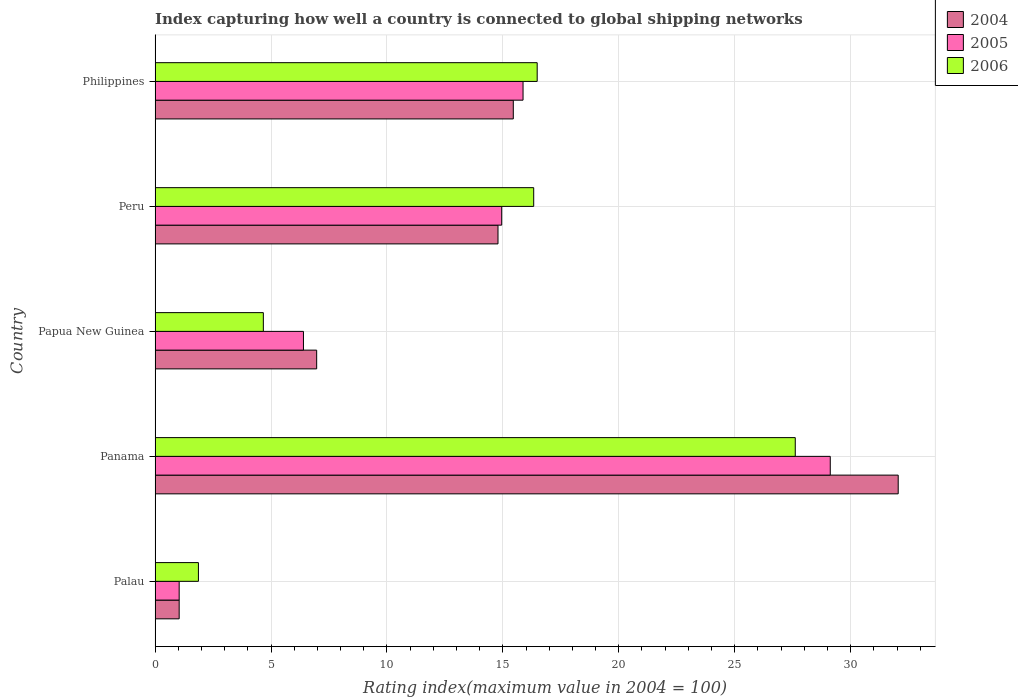How many different coloured bars are there?
Keep it short and to the point. 3. How many groups of bars are there?
Provide a short and direct response. 5. Are the number of bars per tick equal to the number of legend labels?
Offer a very short reply. Yes. What is the label of the 2nd group of bars from the top?
Provide a short and direct response. Peru. What is the rating index in 2004 in Panama?
Your answer should be very brief. 32.05. Across all countries, what is the maximum rating index in 2005?
Keep it short and to the point. 29.12. Across all countries, what is the minimum rating index in 2005?
Make the answer very short. 1.04. In which country was the rating index in 2004 maximum?
Your answer should be very brief. Panama. In which country was the rating index in 2004 minimum?
Your answer should be compact. Palau. What is the total rating index in 2005 in the graph?
Offer a terse response. 67.38. What is the difference between the rating index in 2006 in Papua New Guinea and that in Peru?
Make the answer very short. -11.66. What is the difference between the rating index in 2004 in Peru and the rating index in 2005 in Papua New Guinea?
Your answer should be compact. 8.39. What is the average rating index in 2004 per country?
Give a very brief answer. 14.06. What is the difference between the rating index in 2004 and rating index in 2006 in Palau?
Offer a terse response. -0.83. What is the ratio of the rating index in 2006 in Palau to that in Peru?
Your answer should be very brief. 0.11. Is the rating index in 2006 in Palau less than that in Philippines?
Your answer should be compact. Yes. Is the difference between the rating index in 2004 in Papua New Guinea and Peru greater than the difference between the rating index in 2006 in Papua New Guinea and Peru?
Your response must be concise. Yes. What is the difference between the highest and the second highest rating index in 2004?
Ensure brevity in your answer.  16.6. What is the difference between the highest and the lowest rating index in 2005?
Your answer should be compact. 28.08. In how many countries, is the rating index in 2004 greater than the average rating index in 2004 taken over all countries?
Make the answer very short. 3. What does the 2nd bar from the top in Philippines represents?
Provide a short and direct response. 2005. What does the 3rd bar from the bottom in Panama represents?
Give a very brief answer. 2006. Is it the case that in every country, the sum of the rating index in 2006 and rating index in 2005 is greater than the rating index in 2004?
Ensure brevity in your answer.  Yes. Are all the bars in the graph horizontal?
Offer a terse response. Yes. What is the difference between two consecutive major ticks on the X-axis?
Provide a succinct answer. 5. Are the values on the major ticks of X-axis written in scientific E-notation?
Your response must be concise. No. Does the graph contain any zero values?
Provide a succinct answer. No. Does the graph contain grids?
Offer a terse response. Yes. How many legend labels are there?
Your answer should be compact. 3. What is the title of the graph?
Ensure brevity in your answer.  Index capturing how well a country is connected to global shipping networks. What is the label or title of the X-axis?
Give a very brief answer. Rating index(maximum value in 2004 = 100). What is the Rating index(maximum value in 2004 = 100) in 2006 in Palau?
Your answer should be compact. 1.87. What is the Rating index(maximum value in 2004 = 100) in 2004 in Panama?
Make the answer very short. 32.05. What is the Rating index(maximum value in 2004 = 100) in 2005 in Panama?
Offer a terse response. 29.12. What is the Rating index(maximum value in 2004 = 100) of 2006 in Panama?
Provide a succinct answer. 27.61. What is the Rating index(maximum value in 2004 = 100) in 2004 in Papua New Guinea?
Keep it short and to the point. 6.97. What is the Rating index(maximum value in 2004 = 100) of 2006 in Papua New Guinea?
Your answer should be compact. 4.67. What is the Rating index(maximum value in 2004 = 100) of 2004 in Peru?
Offer a terse response. 14.79. What is the Rating index(maximum value in 2004 = 100) in 2005 in Peru?
Provide a short and direct response. 14.95. What is the Rating index(maximum value in 2004 = 100) in 2006 in Peru?
Provide a short and direct response. 16.33. What is the Rating index(maximum value in 2004 = 100) in 2004 in Philippines?
Provide a short and direct response. 15.45. What is the Rating index(maximum value in 2004 = 100) of 2005 in Philippines?
Your answer should be very brief. 15.87. What is the Rating index(maximum value in 2004 = 100) of 2006 in Philippines?
Provide a short and direct response. 16.48. Across all countries, what is the maximum Rating index(maximum value in 2004 = 100) in 2004?
Give a very brief answer. 32.05. Across all countries, what is the maximum Rating index(maximum value in 2004 = 100) in 2005?
Keep it short and to the point. 29.12. Across all countries, what is the maximum Rating index(maximum value in 2004 = 100) of 2006?
Keep it short and to the point. 27.61. Across all countries, what is the minimum Rating index(maximum value in 2004 = 100) in 2004?
Keep it short and to the point. 1.04. Across all countries, what is the minimum Rating index(maximum value in 2004 = 100) in 2005?
Provide a short and direct response. 1.04. Across all countries, what is the minimum Rating index(maximum value in 2004 = 100) of 2006?
Your answer should be compact. 1.87. What is the total Rating index(maximum value in 2004 = 100) in 2004 in the graph?
Give a very brief answer. 70.3. What is the total Rating index(maximum value in 2004 = 100) of 2005 in the graph?
Keep it short and to the point. 67.38. What is the total Rating index(maximum value in 2004 = 100) in 2006 in the graph?
Offer a terse response. 66.96. What is the difference between the Rating index(maximum value in 2004 = 100) of 2004 in Palau and that in Panama?
Your response must be concise. -31.01. What is the difference between the Rating index(maximum value in 2004 = 100) in 2005 in Palau and that in Panama?
Your response must be concise. -28.08. What is the difference between the Rating index(maximum value in 2004 = 100) of 2006 in Palau and that in Panama?
Make the answer very short. -25.74. What is the difference between the Rating index(maximum value in 2004 = 100) of 2004 in Palau and that in Papua New Guinea?
Ensure brevity in your answer.  -5.93. What is the difference between the Rating index(maximum value in 2004 = 100) in 2005 in Palau and that in Papua New Guinea?
Offer a terse response. -5.36. What is the difference between the Rating index(maximum value in 2004 = 100) of 2006 in Palau and that in Papua New Guinea?
Your response must be concise. -2.8. What is the difference between the Rating index(maximum value in 2004 = 100) of 2004 in Palau and that in Peru?
Provide a short and direct response. -13.75. What is the difference between the Rating index(maximum value in 2004 = 100) of 2005 in Palau and that in Peru?
Keep it short and to the point. -13.91. What is the difference between the Rating index(maximum value in 2004 = 100) of 2006 in Palau and that in Peru?
Your response must be concise. -14.46. What is the difference between the Rating index(maximum value in 2004 = 100) in 2004 in Palau and that in Philippines?
Your answer should be compact. -14.41. What is the difference between the Rating index(maximum value in 2004 = 100) in 2005 in Palau and that in Philippines?
Your response must be concise. -14.83. What is the difference between the Rating index(maximum value in 2004 = 100) of 2006 in Palau and that in Philippines?
Offer a very short reply. -14.61. What is the difference between the Rating index(maximum value in 2004 = 100) in 2004 in Panama and that in Papua New Guinea?
Ensure brevity in your answer.  25.08. What is the difference between the Rating index(maximum value in 2004 = 100) in 2005 in Panama and that in Papua New Guinea?
Your answer should be compact. 22.72. What is the difference between the Rating index(maximum value in 2004 = 100) of 2006 in Panama and that in Papua New Guinea?
Your answer should be very brief. 22.94. What is the difference between the Rating index(maximum value in 2004 = 100) in 2004 in Panama and that in Peru?
Offer a very short reply. 17.26. What is the difference between the Rating index(maximum value in 2004 = 100) in 2005 in Panama and that in Peru?
Give a very brief answer. 14.17. What is the difference between the Rating index(maximum value in 2004 = 100) in 2006 in Panama and that in Peru?
Your response must be concise. 11.28. What is the difference between the Rating index(maximum value in 2004 = 100) of 2004 in Panama and that in Philippines?
Give a very brief answer. 16.6. What is the difference between the Rating index(maximum value in 2004 = 100) of 2005 in Panama and that in Philippines?
Offer a very short reply. 13.25. What is the difference between the Rating index(maximum value in 2004 = 100) in 2006 in Panama and that in Philippines?
Provide a short and direct response. 11.13. What is the difference between the Rating index(maximum value in 2004 = 100) in 2004 in Papua New Guinea and that in Peru?
Keep it short and to the point. -7.82. What is the difference between the Rating index(maximum value in 2004 = 100) of 2005 in Papua New Guinea and that in Peru?
Offer a terse response. -8.55. What is the difference between the Rating index(maximum value in 2004 = 100) in 2006 in Papua New Guinea and that in Peru?
Provide a succinct answer. -11.66. What is the difference between the Rating index(maximum value in 2004 = 100) in 2004 in Papua New Guinea and that in Philippines?
Your answer should be compact. -8.48. What is the difference between the Rating index(maximum value in 2004 = 100) of 2005 in Papua New Guinea and that in Philippines?
Your response must be concise. -9.47. What is the difference between the Rating index(maximum value in 2004 = 100) of 2006 in Papua New Guinea and that in Philippines?
Your response must be concise. -11.81. What is the difference between the Rating index(maximum value in 2004 = 100) of 2004 in Peru and that in Philippines?
Your answer should be very brief. -0.66. What is the difference between the Rating index(maximum value in 2004 = 100) in 2005 in Peru and that in Philippines?
Your answer should be compact. -0.92. What is the difference between the Rating index(maximum value in 2004 = 100) of 2004 in Palau and the Rating index(maximum value in 2004 = 100) of 2005 in Panama?
Offer a very short reply. -28.08. What is the difference between the Rating index(maximum value in 2004 = 100) in 2004 in Palau and the Rating index(maximum value in 2004 = 100) in 2006 in Panama?
Provide a short and direct response. -26.57. What is the difference between the Rating index(maximum value in 2004 = 100) of 2005 in Palau and the Rating index(maximum value in 2004 = 100) of 2006 in Panama?
Ensure brevity in your answer.  -26.57. What is the difference between the Rating index(maximum value in 2004 = 100) in 2004 in Palau and the Rating index(maximum value in 2004 = 100) in 2005 in Papua New Guinea?
Keep it short and to the point. -5.36. What is the difference between the Rating index(maximum value in 2004 = 100) in 2004 in Palau and the Rating index(maximum value in 2004 = 100) in 2006 in Papua New Guinea?
Offer a terse response. -3.63. What is the difference between the Rating index(maximum value in 2004 = 100) of 2005 in Palau and the Rating index(maximum value in 2004 = 100) of 2006 in Papua New Guinea?
Provide a short and direct response. -3.63. What is the difference between the Rating index(maximum value in 2004 = 100) of 2004 in Palau and the Rating index(maximum value in 2004 = 100) of 2005 in Peru?
Make the answer very short. -13.91. What is the difference between the Rating index(maximum value in 2004 = 100) in 2004 in Palau and the Rating index(maximum value in 2004 = 100) in 2006 in Peru?
Offer a very short reply. -15.29. What is the difference between the Rating index(maximum value in 2004 = 100) of 2005 in Palau and the Rating index(maximum value in 2004 = 100) of 2006 in Peru?
Provide a succinct answer. -15.29. What is the difference between the Rating index(maximum value in 2004 = 100) of 2004 in Palau and the Rating index(maximum value in 2004 = 100) of 2005 in Philippines?
Give a very brief answer. -14.83. What is the difference between the Rating index(maximum value in 2004 = 100) in 2004 in Palau and the Rating index(maximum value in 2004 = 100) in 2006 in Philippines?
Make the answer very short. -15.44. What is the difference between the Rating index(maximum value in 2004 = 100) in 2005 in Palau and the Rating index(maximum value in 2004 = 100) in 2006 in Philippines?
Your response must be concise. -15.44. What is the difference between the Rating index(maximum value in 2004 = 100) of 2004 in Panama and the Rating index(maximum value in 2004 = 100) of 2005 in Papua New Guinea?
Offer a terse response. 25.65. What is the difference between the Rating index(maximum value in 2004 = 100) in 2004 in Panama and the Rating index(maximum value in 2004 = 100) in 2006 in Papua New Guinea?
Make the answer very short. 27.38. What is the difference between the Rating index(maximum value in 2004 = 100) in 2005 in Panama and the Rating index(maximum value in 2004 = 100) in 2006 in Papua New Guinea?
Provide a succinct answer. 24.45. What is the difference between the Rating index(maximum value in 2004 = 100) in 2004 in Panama and the Rating index(maximum value in 2004 = 100) in 2006 in Peru?
Your answer should be compact. 15.72. What is the difference between the Rating index(maximum value in 2004 = 100) in 2005 in Panama and the Rating index(maximum value in 2004 = 100) in 2006 in Peru?
Offer a very short reply. 12.79. What is the difference between the Rating index(maximum value in 2004 = 100) in 2004 in Panama and the Rating index(maximum value in 2004 = 100) in 2005 in Philippines?
Ensure brevity in your answer.  16.18. What is the difference between the Rating index(maximum value in 2004 = 100) of 2004 in Panama and the Rating index(maximum value in 2004 = 100) of 2006 in Philippines?
Your answer should be compact. 15.57. What is the difference between the Rating index(maximum value in 2004 = 100) of 2005 in Panama and the Rating index(maximum value in 2004 = 100) of 2006 in Philippines?
Ensure brevity in your answer.  12.64. What is the difference between the Rating index(maximum value in 2004 = 100) of 2004 in Papua New Guinea and the Rating index(maximum value in 2004 = 100) of 2005 in Peru?
Your response must be concise. -7.98. What is the difference between the Rating index(maximum value in 2004 = 100) in 2004 in Papua New Guinea and the Rating index(maximum value in 2004 = 100) in 2006 in Peru?
Your response must be concise. -9.36. What is the difference between the Rating index(maximum value in 2004 = 100) of 2005 in Papua New Guinea and the Rating index(maximum value in 2004 = 100) of 2006 in Peru?
Your answer should be compact. -9.93. What is the difference between the Rating index(maximum value in 2004 = 100) in 2004 in Papua New Guinea and the Rating index(maximum value in 2004 = 100) in 2005 in Philippines?
Ensure brevity in your answer.  -8.9. What is the difference between the Rating index(maximum value in 2004 = 100) of 2004 in Papua New Guinea and the Rating index(maximum value in 2004 = 100) of 2006 in Philippines?
Provide a short and direct response. -9.51. What is the difference between the Rating index(maximum value in 2004 = 100) in 2005 in Papua New Guinea and the Rating index(maximum value in 2004 = 100) in 2006 in Philippines?
Keep it short and to the point. -10.08. What is the difference between the Rating index(maximum value in 2004 = 100) of 2004 in Peru and the Rating index(maximum value in 2004 = 100) of 2005 in Philippines?
Your answer should be compact. -1.08. What is the difference between the Rating index(maximum value in 2004 = 100) in 2004 in Peru and the Rating index(maximum value in 2004 = 100) in 2006 in Philippines?
Keep it short and to the point. -1.69. What is the difference between the Rating index(maximum value in 2004 = 100) in 2005 in Peru and the Rating index(maximum value in 2004 = 100) in 2006 in Philippines?
Your response must be concise. -1.53. What is the average Rating index(maximum value in 2004 = 100) of 2004 per country?
Give a very brief answer. 14.06. What is the average Rating index(maximum value in 2004 = 100) of 2005 per country?
Offer a terse response. 13.48. What is the average Rating index(maximum value in 2004 = 100) in 2006 per country?
Offer a very short reply. 13.39. What is the difference between the Rating index(maximum value in 2004 = 100) in 2004 and Rating index(maximum value in 2004 = 100) in 2006 in Palau?
Keep it short and to the point. -0.83. What is the difference between the Rating index(maximum value in 2004 = 100) in 2005 and Rating index(maximum value in 2004 = 100) in 2006 in Palau?
Your response must be concise. -0.83. What is the difference between the Rating index(maximum value in 2004 = 100) of 2004 and Rating index(maximum value in 2004 = 100) of 2005 in Panama?
Make the answer very short. 2.93. What is the difference between the Rating index(maximum value in 2004 = 100) in 2004 and Rating index(maximum value in 2004 = 100) in 2006 in Panama?
Your response must be concise. 4.44. What is the difference between the Rating index(maximum value in 2004 = 100) in 2005 and Rating index(maximum value in 2004 = 100) in 2006 in Panama?
Your answer should be very brief. 1.51. What is the difference between the Rating index(maximum value in 2004 = 100) of 2004 and Rating index(maximum value in 2004 = 100) of 2005 in Papua New Guinea?
Ensure brevity in your answer.  0.57. What is the difference between the Rating index(maximum value in 2004 = 100) in 2005 and Rating index(maximum value in 2004 = 100) in 2006 in Papua New Guinea?
Give a very brief answer. 1.73. What is the difference between the Rating index(maximum value in 2004 = 100) in 2004 and Rating index(maximum value in 2004 = 100) in 2005 in Peru?
Provide a short and direct response. -0.16. What is the difference between the Rating index(maximum value in 2004 = 100) of 2004 and Rating index(maximum value in 2004 = 100) of 2006 in Peru?
Provide a succinct answer. -1.54. What is the difference between the Rating index(maximum value in 2004 = 100) in 2005 and Rating index(maximum value in 2004 = 100) in 2006 in Peru?
Offer a terse response. -1.38. What is the difference between the Rating index(maximum value in 2004 = 100) in 2004 and Rating index(maximum value in 2004 = 100) in 2005 in Philippines?
Give a very brief answer. -0.42. What is the difference between the Rating index(maximum value in 2004 = 100) of 2004 and Rating index(maximum value in 2004 = 100) of 2006 in Philippines?
Your answer should be compact. -1.03. What is the difference between the Rating index(maximum value in 2004 = 100) of 2005 and Rating index(maximum value in 2004 = 100) of 2006 in Philippines?
Provide a short and direct response. -0.61. What is the ratio of the Rating index(maximum value in 2004 = 100) in 2004 in Palau to that in Panama?
Offer a terse response. 0.03. What is the ratio of the Rating index(maximum value in 2004 = 100) in 2005 in Palau to that in Panama?
Provide a short and direct response. 0.04. What is the ratio of the Rating index(maximum value in 2004 = 100) in 2006 in Palau to that in Panama?
Your response must be concise. 0.07. What is the ratio of the Rating index(maximum value in 2004 = 100) of 2004 in Palau to that in Papua New Guinea?
Your answer should be very brief. 0.15. What is the ratio of the Rating index(maximum value in 2004 = 100) of 2005 in Palau to that in Papua New Guinea?
Your response must be concise. 0.16. What is the ratio of the Rating index(maximum value in 2004 = 100) of 2006 in Palau to that in Papua New Guinea?
Your answer should be very brief. 0.4. What is the ratio of the Rating index(maximum value in 2004 = 100) in 2004 in Palau to that in Peru?
Your response must be concise. 0.07. What is the ratio of the Rating index(maximum value in 2004 = 100) in 2005 in Palau to that in Peru?
Provide a succinct answer. 0.07. What is the ratio of the Rating index(maximum value in 2004 = 100) in 2006 in Palau to that in Peru?
Offer a terse response. 0.11. What is the ratio of the Rating index(maximum value in 2004 = 100) in 2004 in Palau to that in Philippines?
Offer a very short reply. 0.07. What is the ratio of the Rating index(maximum value in 2004 = 100) in 2005 in Palau to that in Philippines?
Offer a very short reply. 0.07. What is the ratio of the Rating index(maximum value in 2004 = 100) in 2006 in Palau to that in Philippines?
Your response must be concise. 0.11. What is the ratio of the Rating index(maximum value in 2004 = 100) in 2004 in Panama to that in Papua New Guinea?
Provide a succinct answer. 4.6. What is the ratio of the Rating index(maximum value in 2004 = 100) of 2005 in Panama to that in Papua New Guinea?
Ensure brevity in your answer.  4.55. What is the ratio of the Rating index(maximum value in 2004 = 100) of 2006 in Panama to that in Papua New Guinea?
Your answer should be very brief. 5.91. What is the ratio of the Rating index(maximum value in 2004 = 100) of 2004 in Panama to that in Peru?
Provide a succinct answer. 2.17. What is the ratio of the Rating index(maximum value in 2004 = 100) of 2005 in Panama to that in Peru?
Your answer should be very brief. 1.95. What is the ratio of the Rating index(maximum value in 2004 = 100) in 2006 in Panama to that in Peru?
Give a very brief answer. 1.69. What is the ratio of the Rating index(maximum value in 2004 = 100) of 2004 in Panama to that in Philippines?
Keep it short and to the point. 2.07. What is the ratio of the Rating index(maximum value in 2004 = 100) of 2005 in Panama to that in Philippines?
Make the answer very short. 1.83. What is the ratio of the Rating index(maximum value in 2004 = 100) in 2006 in Panama to that in Philippines?
Provide a short and direct response. 1.68. What is the ratio of the Rating index(maximum value in 2004 = 100) of 2004 in Papua New Guinea to that in Peru?
Make the answer very short. 0.47. What is the ratio of the Rating index(maximum value in 2004 = 100) of 2005 in Papua New Guinea to that in Peru?
Provide a short and direct response. 0.43. What is the ratio of the Rating index(maximum value in 2004 = 100) of 2006 in Papua New Guinea to that in Peru?
Provide a succinct answer. 0.29. What is the ratio of the Rating index(maximum value in 2004 = 100) of 2004 in Papua New Guinea to that in Philippines?
Your response must be concise. 0.45. What is the ratio of the Rating index(maximum value in 2004 = 100) of 2005 in Papua New Guinea to that in Philippines?
Your response must be concise. 0.4. What is the ratio of the Rating index(maximum value in 2004 = 100) in 2006 in Papua New Guinea to that in Philippines?
Your answer should be very brief. 0.28. What is the ratio of the Rating index(maximum value in 2004 = 100) in 2004 in Peru to that in Philippines?
Keep it short and to the point. 0.96. What is the ratio of the Rating index(maximum value in 2004 = 100) of 2005 in Peru to that in Philippines?
Ensure brevity in your answer.  0.94. What is the ratio of the Rating index(maximum value in 2004 = 100) in 2006 in Peru to that in Philippines?
Give a very brief answer. 0.99. What is the difference between the highest and the second highest Rating index(maximum value in 2004 = 100) in 2004?
Provide a short and direct response. 16.6. What is the difference between the highest and the second highest Rating index(maximum value in 2004 = 100) in 2005?
Your answer should be compact. 13.25. What is the difference between the highest and the second highest Rating index(maximum value in 2004 = 100) of 2006?
Give a very brief answer. 11.13. What is the difference between the highest and the lowest Rating index(maximum value in 2004 = 100) of 2004?
Give a very brief answer. 31.01. What is the difference between the highest and the lowest Rating index(maximum value in 2004 = 100) in 2005?
Provide a short and direct response. 28.08. What is the difference between the highest and the lowest Rating index(maximum value in 2004 = 100) in 2006?
Make the answer very short. 25.74. 